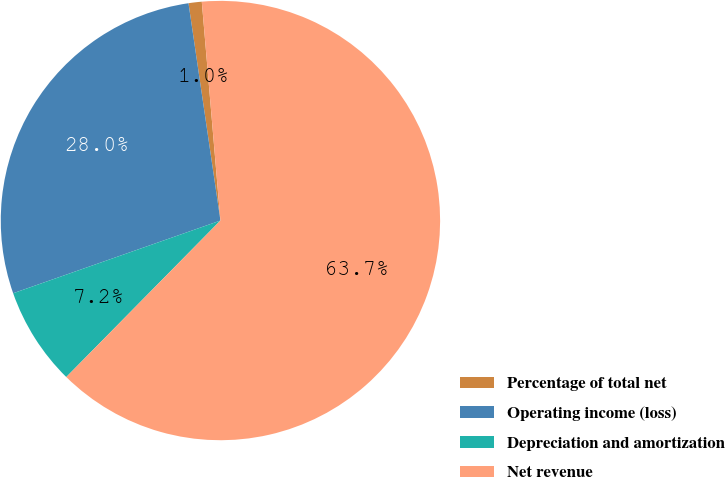Convert chart to OTSL. <chart><loc_0><loc_0><loc_500><loc_500><pie_chart><fcel>Percentage of total net<fcel>Operating income (loss)<fcel>Depreciation and amortization<fcel>Net revenue<nl><fcel>0.97%<fcel>28.05%<fcel>7.25%<fcel>63.74%<nl></chart> 